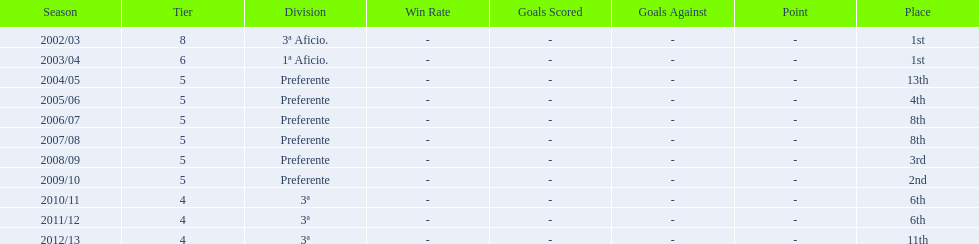Which seasons were played in tier four? 2010/11, 2011/12, 2012/13. Of these seasons, which resulted in 6th place? 2010/11, 2011/12. Which of the remaining happened last? 2011/12. 